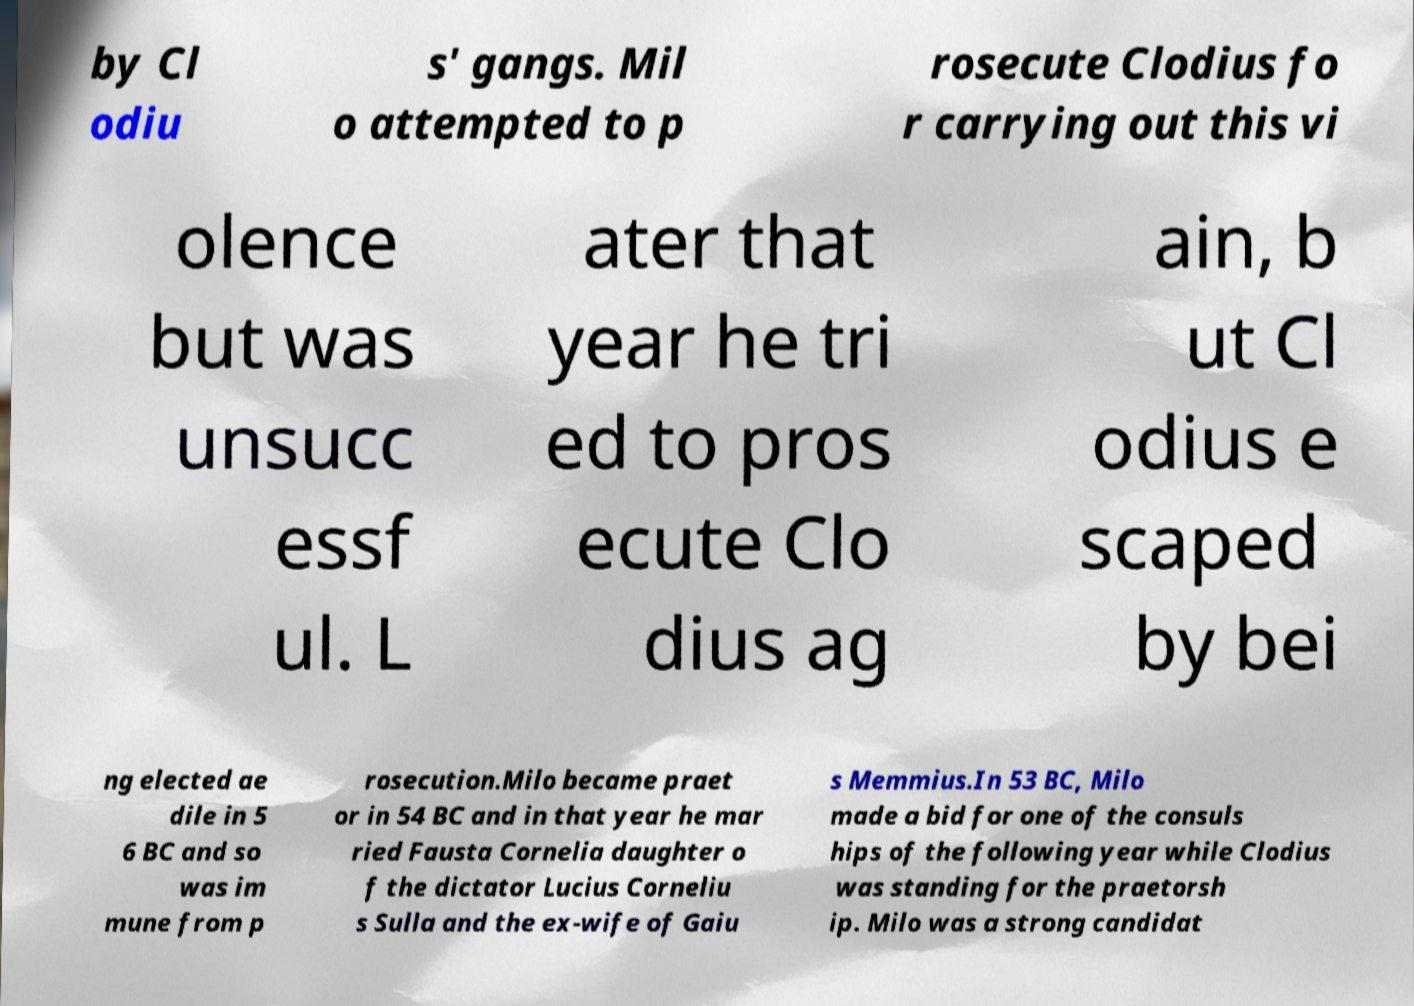What messages or text are displayed in this image? I need them in a readable, typed format. by Cl odiu s' gangs. Mil o attempted to p rosecute Clodius fo r carrying out this vi olence but was unsucc essf ul. L ater that year he tri ed to pros ecute Clo dius ag ain, b ut Cl odius e scaped by bei ng elected ae dile in 5 6 BC and so was im mune from p rosecution.Milo became praet or in 54 BC and in that year he mar ried Fausta Cornelia daughter o f the dictator Lucius Corneliu s Sulla and the ex-wife of Gaiu s Memmius.In 53 BC, Milo made a bid for one of the consuls hips of the following year while Clodius was standing for the praetorsh ip. Milo was a strong candidat 